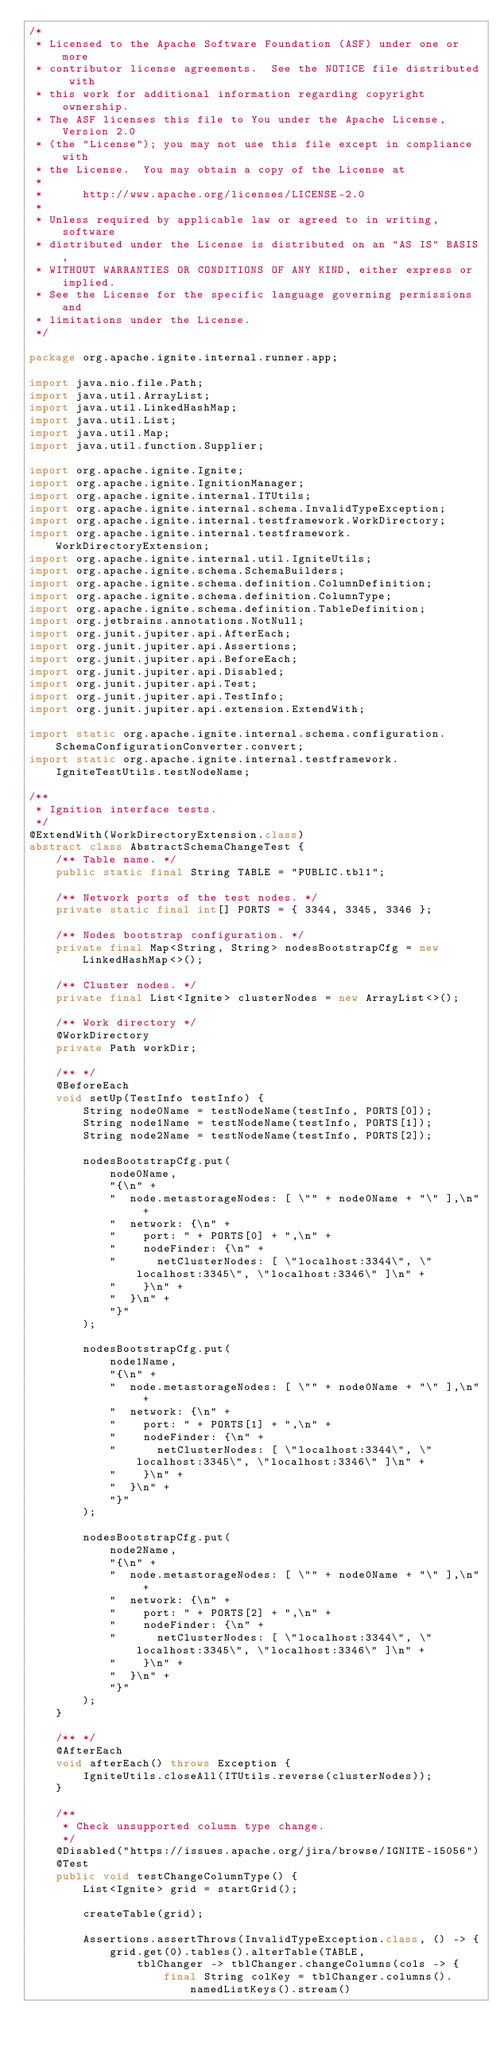Convert code to text. <code><loc_0><loc_0><loc_500><loc_500><_Java_>/*
 * Licensed to the Apache Software Foundation (ASF) under one or more
 * contributor license agreements.  See the NOTICE file distributed with
 * this work for additional information regarding copyright ownership.
 * The ASF licenses this file to You under the Apache License, Version 2.0
 * (the "License"); you may not use this file except in compliance with
 * the License.  You may obtain a copy of the License at
 *
 *      http://www.apache.org/licenses/LICENSE-2.0
 *
 * Unless required by applicable law or agreed to in writing, software
 * distributed under the License is distributed on an "AS IS" BASIS,
 * WITHOUT WARRANTIES OR CONDITIONS OF ANY KIND, either express or implied.
 * See the License for the specific language governing permissions and
 * limitations under the License.
 */

package org.apache.ignite.internal.runner.app;

import java.nio.file.Path;
import java.util.ArrayList;
import java.util.LinkedHashMap;
import java.util.List;
import java.util.Map;
import java.util.function.Supplier;

import org.apache.ignite.Ignite;
import org.apache.ignite.IgnitionManager;
import org.apache.ignite.internal.ITUtils;
import org.apache.ignite.internal.schema.InvalidTypeException;
import org.apache.ignite.internal.testframework.WorkDirectory;
import org.apache.ignite.internal.testframework.WorkDirectoryExtension;
import org.apache.ignite.internal.util.IgniteUtils;
import org.apache.ignite.schema.SchemaBuilders;
import org.apache.ignite.schema.definition.ColumnDefinition;
import org.apache.ignite.schema.definition.ColumnType;
import org.apache.ignite.schema.definition.TableDefinition;
import org.jetbrains.annotations.NotNull;
import org.junit.jupiter.api.AfterEach;
import org.junit.jupiter.api.Assertions;
import org.junit.jupiter.api.BeforeEach;
import org.junit.jupiter.api.Disabled;
import org.junit.jupiter.api.Test;
import org.junit.jupiter.api.TestInfo;
import org.junit.jupiter.api.extension.ExtendWith;

import static org.apache.ignite.internal.schema.configuration.SchemaConfigurationConverter.convert;
import static org.apache.ignite.internal.testframework.IgniteTestUtils.testNodeName;

/**
 * Ignition interface tests.
 */
@ExtendWith(WorkDirectoryExtension.class)
abstract class AbstractSchemaChangeTest {
    /** Table name. */
    public static final String TABLE = "PUBLIC.tbl1";

    /** Network ports of the test nodes. */
    private static final int[] PORTS = { 3344, 3345, 3346 };

    /** Nodes bootstrap configuration. */
    private final Map<String, String> nodesBootstrapCfg = new LinkedHashMap<>();

    /** Cluster nodes. */
    private final List<Ignite> clusterNodes = new ArrayList<>();

    /** Work directory */
    @WorkDirectory
    private Path workDir;

    /** */
    @BeforeEach
    void setUp(TestInfo testInfo) {
        String node0Name = testNodeName(testInfo, PORTS[0]);
        String node1Name = testNodeName(testInfo, PORTS[1]);
        String node2Name = testNodeName(testInfo, PORTS[2]);

        nodesBootstrapCfg.put(
            node0Name,
            "{\n" +
            "  node.metastorageNodes: [ \"" + node0Name + "\" ],\n" +
            "  network: {\n" +
            "    port: " + PORTS[0] + ",\n" +
            "    nodeFinder: {\n" +
            "      netClusterNodes: [ \"localhost:3344\", \"localhost:3345\", \"localhost:3346\" ]\n" +
            "    }\n" +
            "  }\n" +
            "}"
        );

        nodesBootstrapCfg.put(
            node1Name,
            "{\n" +
            "  node.metastorageNodes: [ \"" + node0Name + "\" ],\n" +
            "  network: {\n" +
            "    port: " + PORTS[1] + ",\n" +
            "    nodeFinder: {\n" +
            "      netClusterNodes: [ \"localhost:3344\", \"localhost:3345\", \"localhost:3346\" ]\n" +
            "    }\n" +
            "  }\n" +
            "}"
        );

        nodesBootstrapCfg.put(
            node2Name,
            "{\n" +
            "  node.metastorageNodes: [ \"" + node0Name + "\" ],\n" +
            "  network: {\n" +
            "    port: " + PORTS[2] + ",\n" +
            "    nodeFinder: {\n" +
            "      netClusterNodes: [ \"localhost:3344\", \"localhost:3345\", \"localhost:3346\" ]\n" +
            "    }\n" +
            "  }\n" +
            "}"
        );
    }

    /** */
    @AfterEach
    void afterEach() throws Exception {
        IgniteUtils.closeAll(ITUtils.reverse(clusterNodes));
    }

    /**
     * Check unsupported column type change.
     */
    @Disabled("https://issues.apache.org/jira/browse/IGNITE-15056")
    @Test
    public void testChangeColumnType() {
        List<Ignite> grid = startGrid();

        createTable(grid);

        Assertions.assertThrows(InvalidTypeException.class, () -> {
            grid.get(0).tables().alterTable(TABLE,
                tblChanger -> tblChanger.changeColumns(cols -> {
                    final String colKey = tblChanger.columns().namedListKeys().stream()</code> 